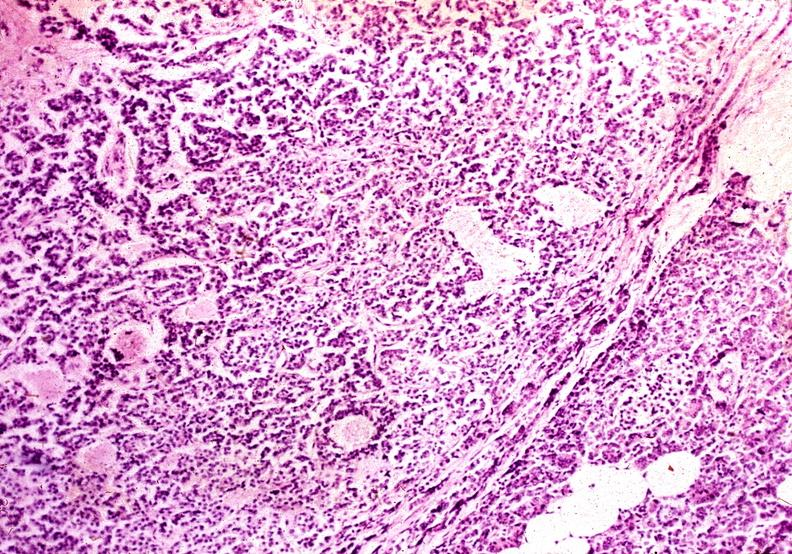what is present?
Answer the question using a single word or phrase. Pancreas 